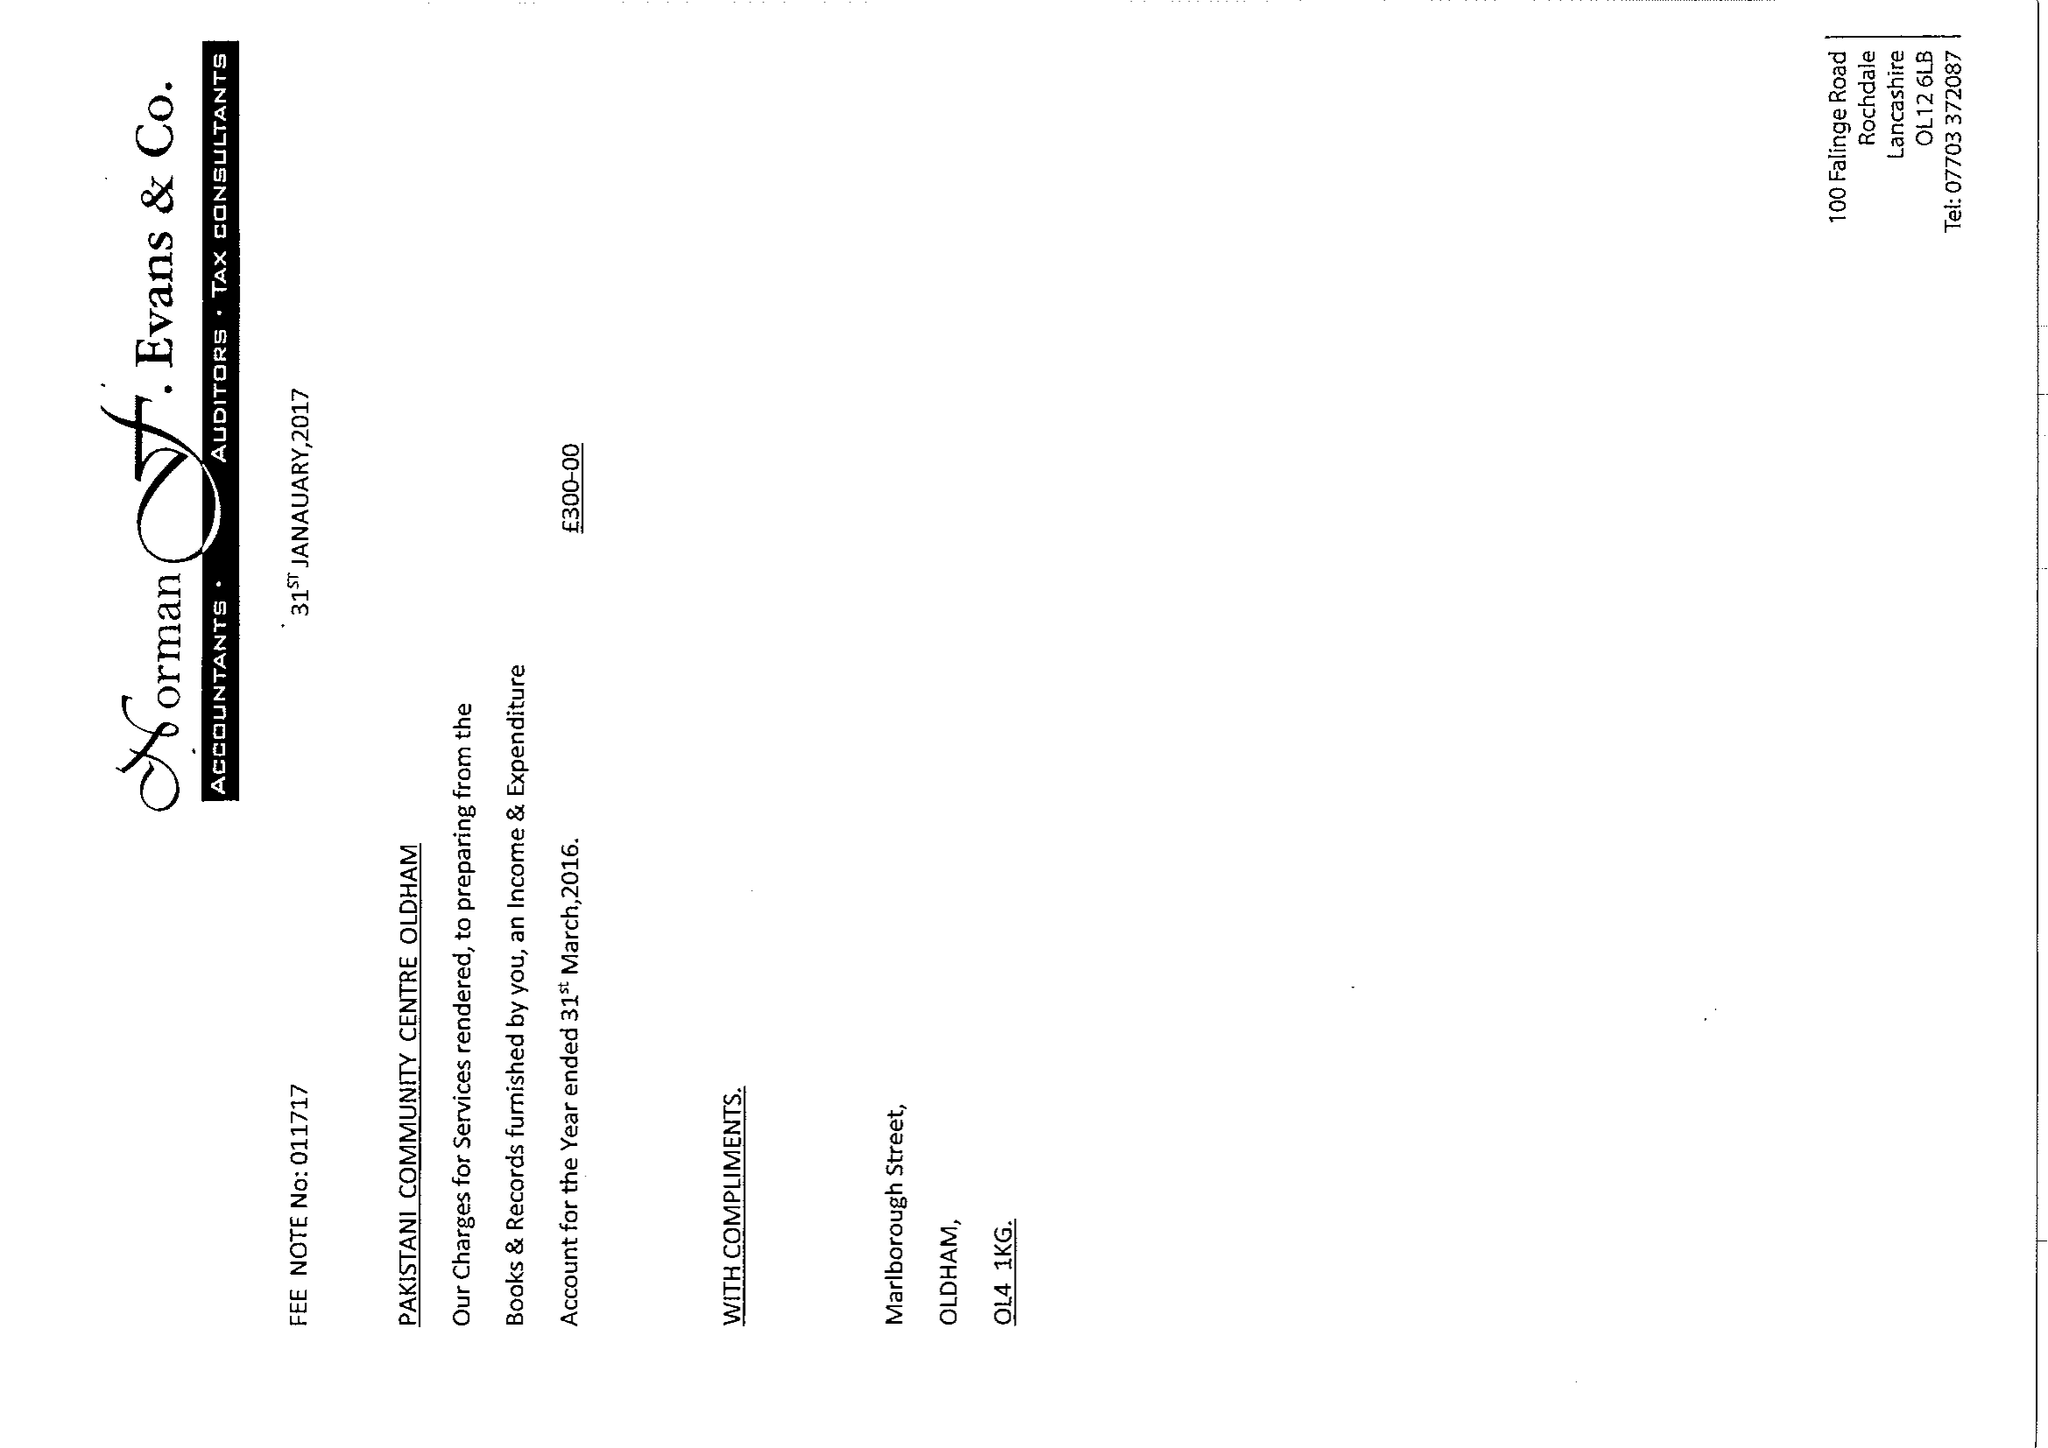What is the value for the charity_number?
Answer the question using a single word or phrase. 1148619 